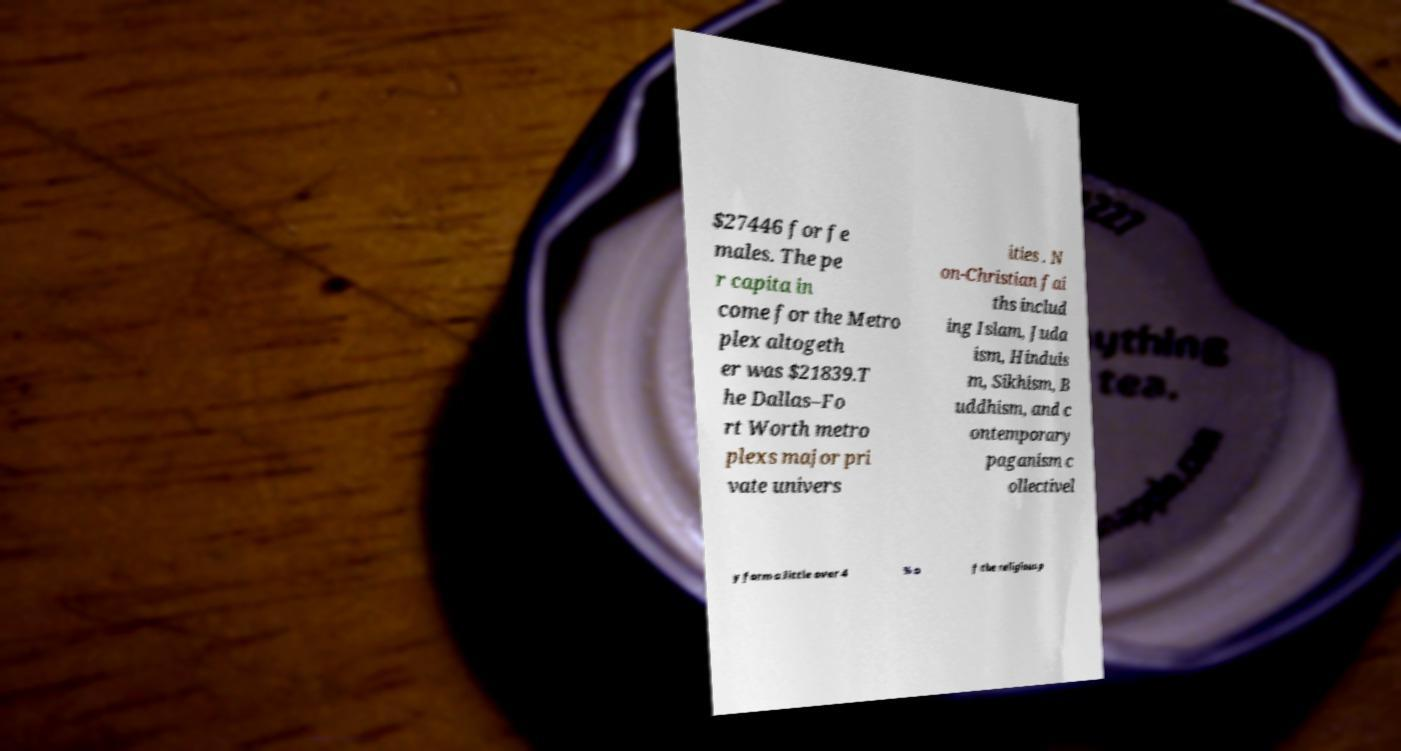Can you accurately transcribe the text from the provided image for me? $27446 for fe males. The pe r capita in come for the Metro plex altogeth er was $21839.T he Dallas–Fo rt Worth metro plexs major pri vate univers ities . N on-Christian fai ths includ ing Islam, Juda ism, Hinduis m, Sikhism, B uddhism, and c ontemporary paganism c ollectivel y form a little over 4 % o f the religious p 